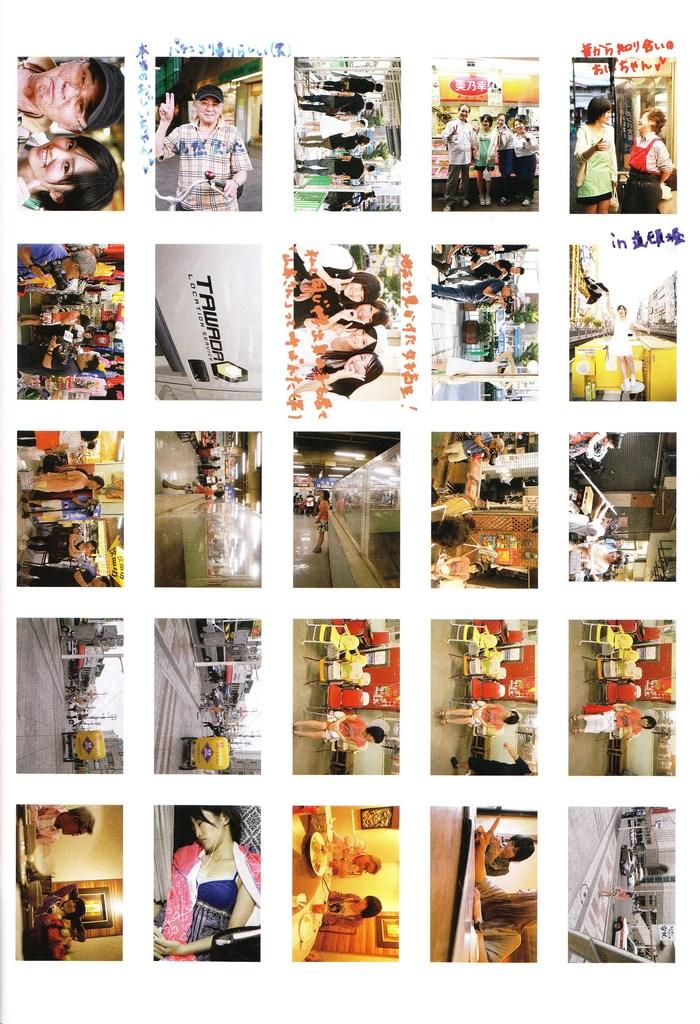Who or what is present in the image? There are people in the image. What furniture is visible in the image? There are chairs and a table with plates in the image. What can be seen on the road in the image? Vehicles are visible on the road in the image. What is hanging on the wall in the image? There is a picture on the wall in the image. How many ladybugs are crawling on the table in the image? There are no ladybugs present in the image. What type of toys can be seen on the floor in the image? There is no mention of toys in the image; it only includes people, chairs, a table with plates, vehicles on the road, and a picture on the wall. 